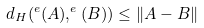<formula> <loc_0><loc_0><loc_500><loc_500>d _ { H } ( ^ { e } ( A ) , ^ { e } ( B ) ) \leq \| A - B \|</formula> 